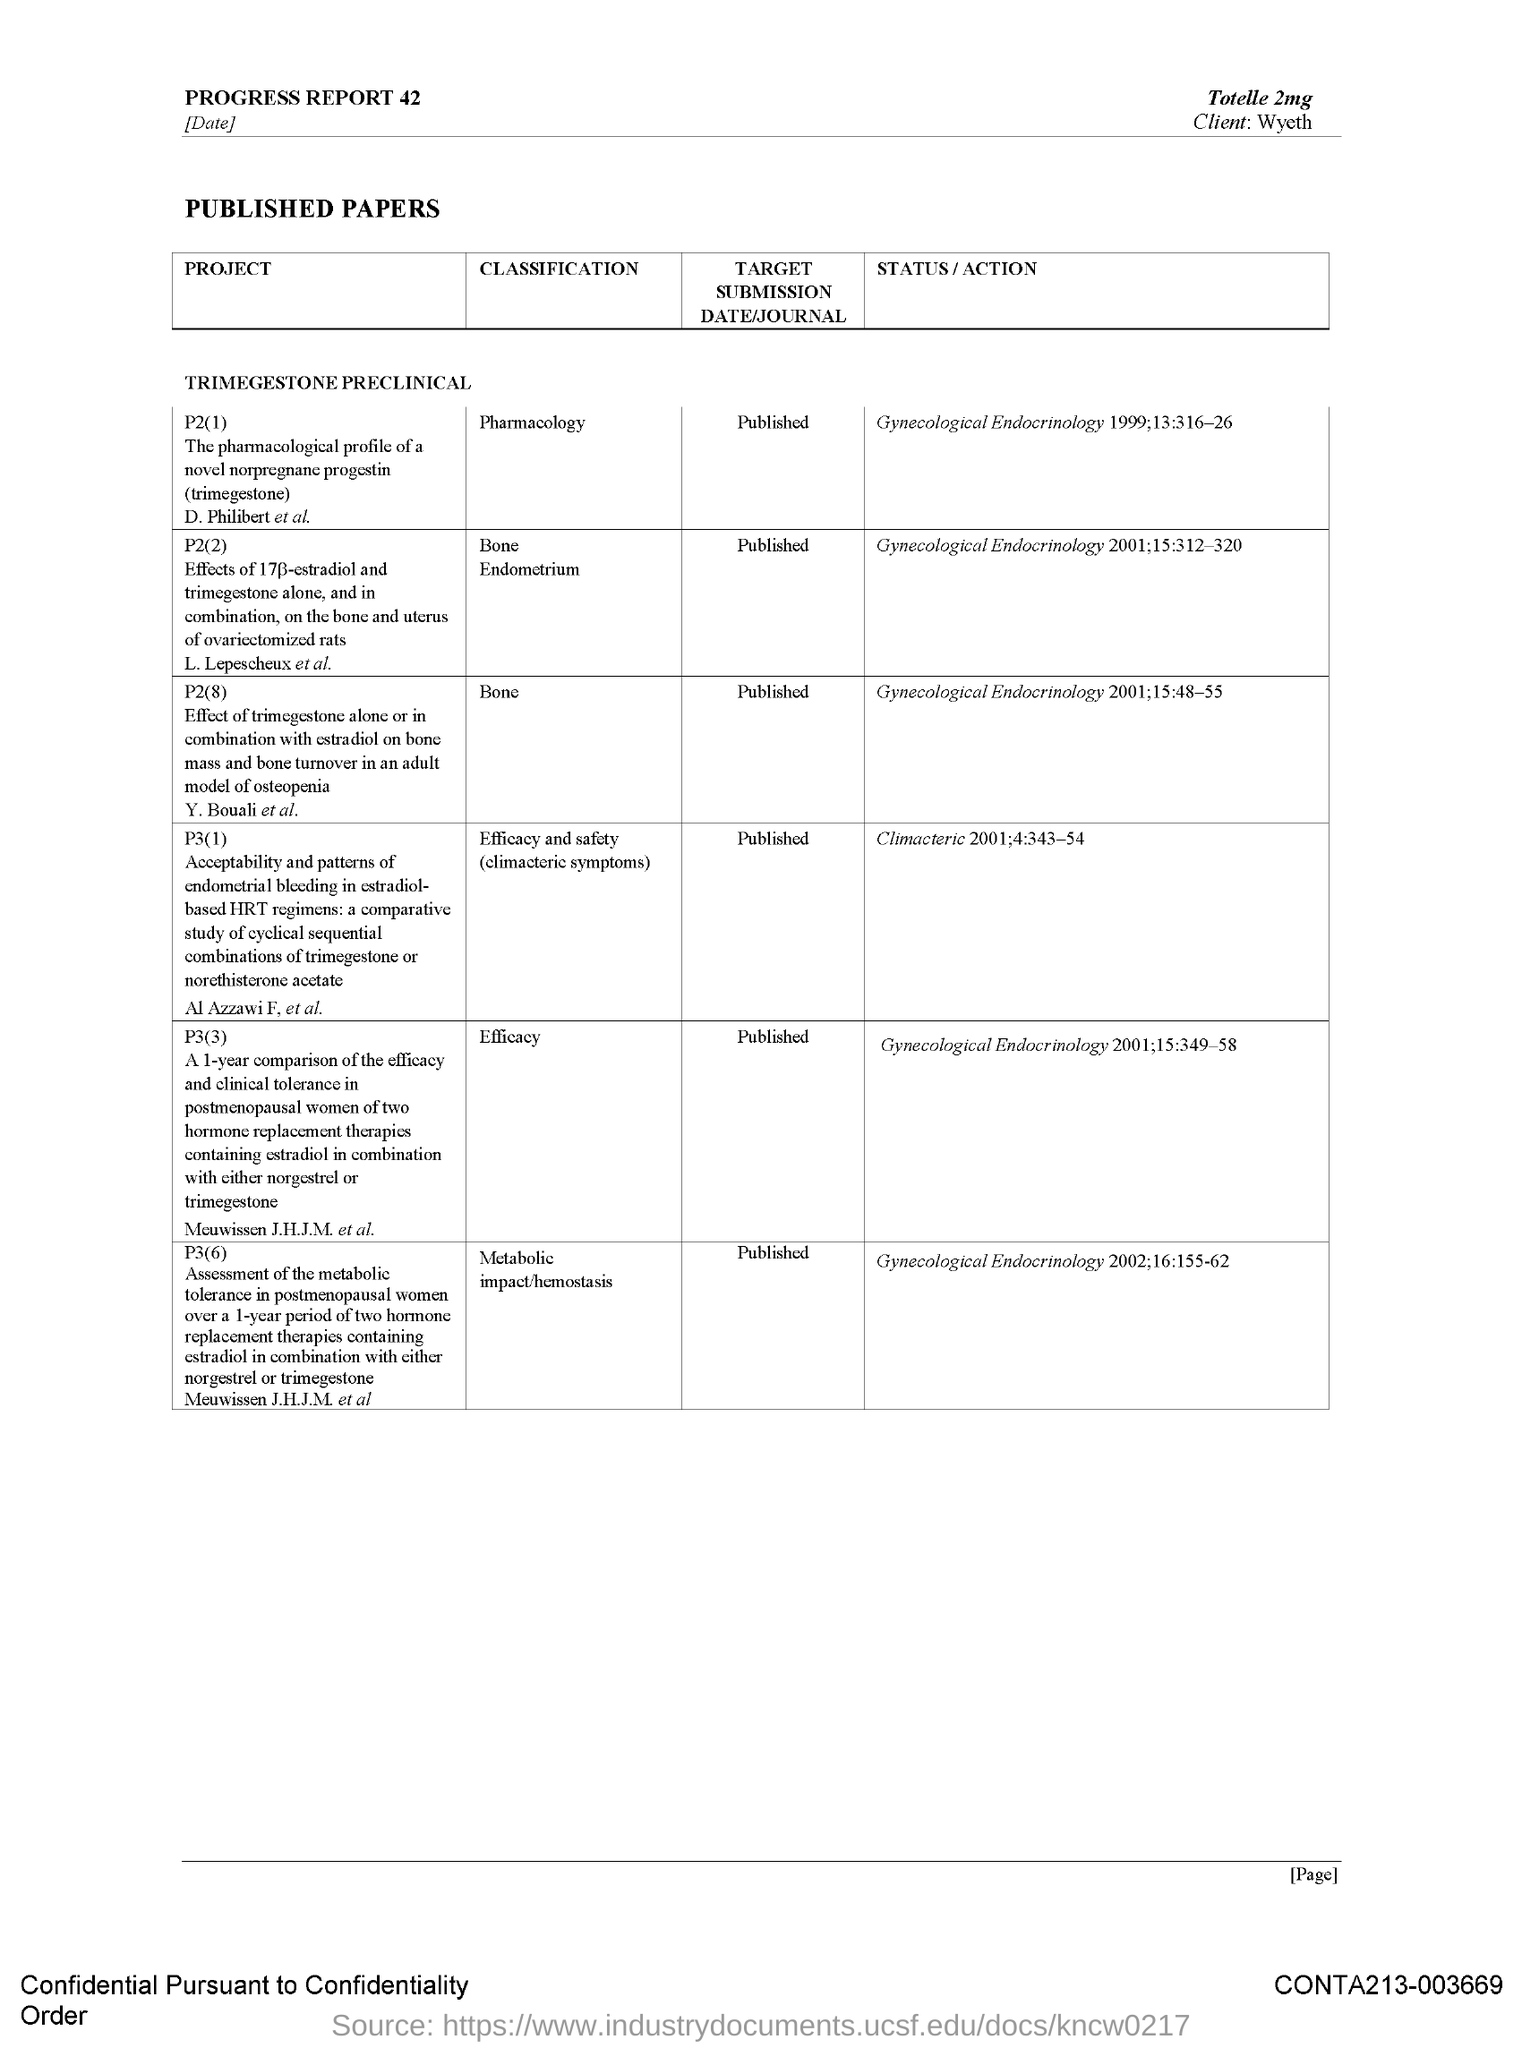What is classification of p2(8)?
Offer a terse response. Bone. 